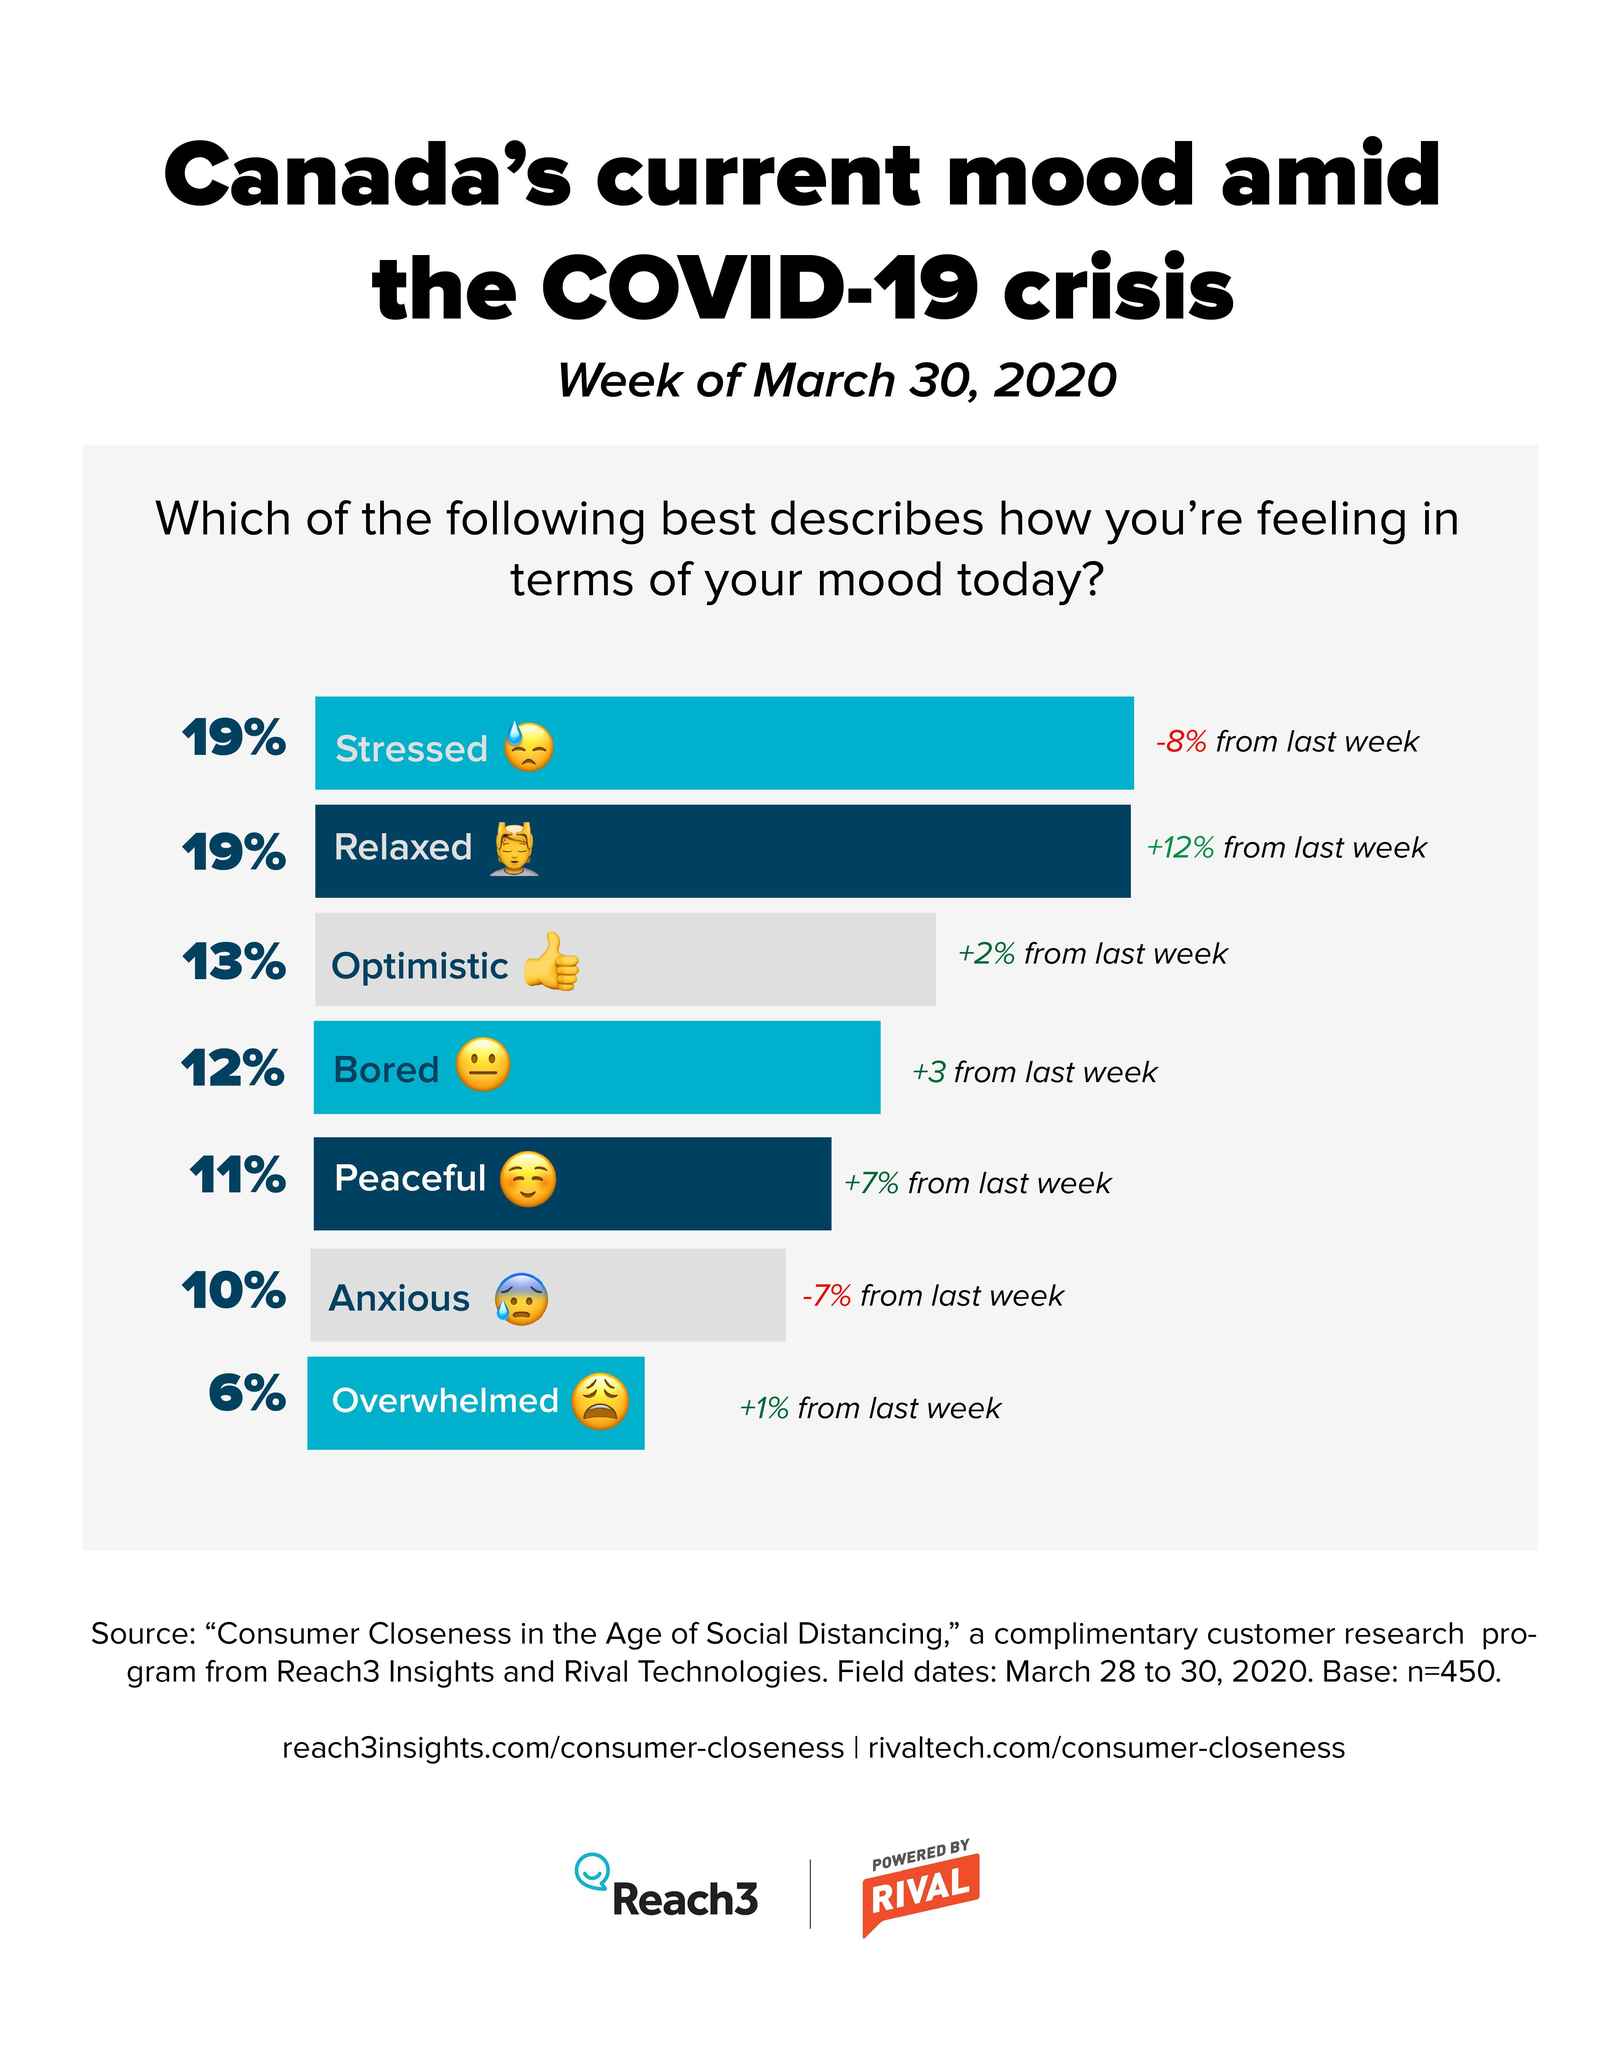What percent of the Canadians felt overwhelmed amid the COVID-19 crisis according to the survey conducted in the week of March 30, 2020?
Answer the question with a short phrase. 6% What percent of the Canadians felt anxious amid the COVID-19 crisis according to the survey conducted in the week of March 30, 2020? 10% What percent of the Canadians felt bored amid the COVID-19 crisis according to the survey conducted in the week of March 30, 2020? 12% What percent of the Canadians felt peaceful amid the COVID-19 crisis according to the survey conducted in the week of March 30, 2020? 11% What percent of the Canadians felt stressed amid the COVID-19 crisis according to the survey conducted in the week of March 30, 2020? 19% 